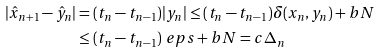Convert formula to latex. <formula><loc_0><loc_0><loc_500><loc_500>| \hat { x } _ { n + 1 } - \hat { y } _ { n } | & = ( t _ { n } - t _ { n - 1 } ) | y _ { n } | \leq ( t _ { n } - t _ { n - 1 } ) \delta ( x _ { n } , y _ { n } ) + b N \\ & \leq ( t _ { n } - t _ { n - 1 } ) \ e p s + b N = c \Delta _ { n }</formula> 